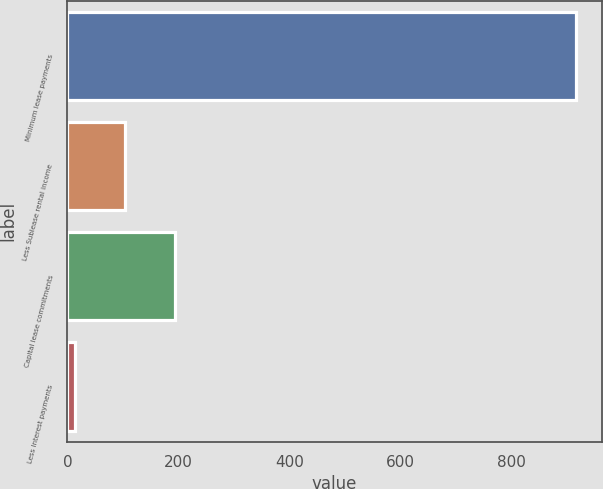Convert chart to OTSL. <chart><loc_0><loc_0><loc_500><loc_500><bar_chart><fcel>Minimum lease payments<fcel>Less Sublease rental income<fcel>Capital lease commitments<fcel>Less Interest payments<nl><fcel>917<fcel>104.3<fcel>194.6<fcel>14<nl></chart> 